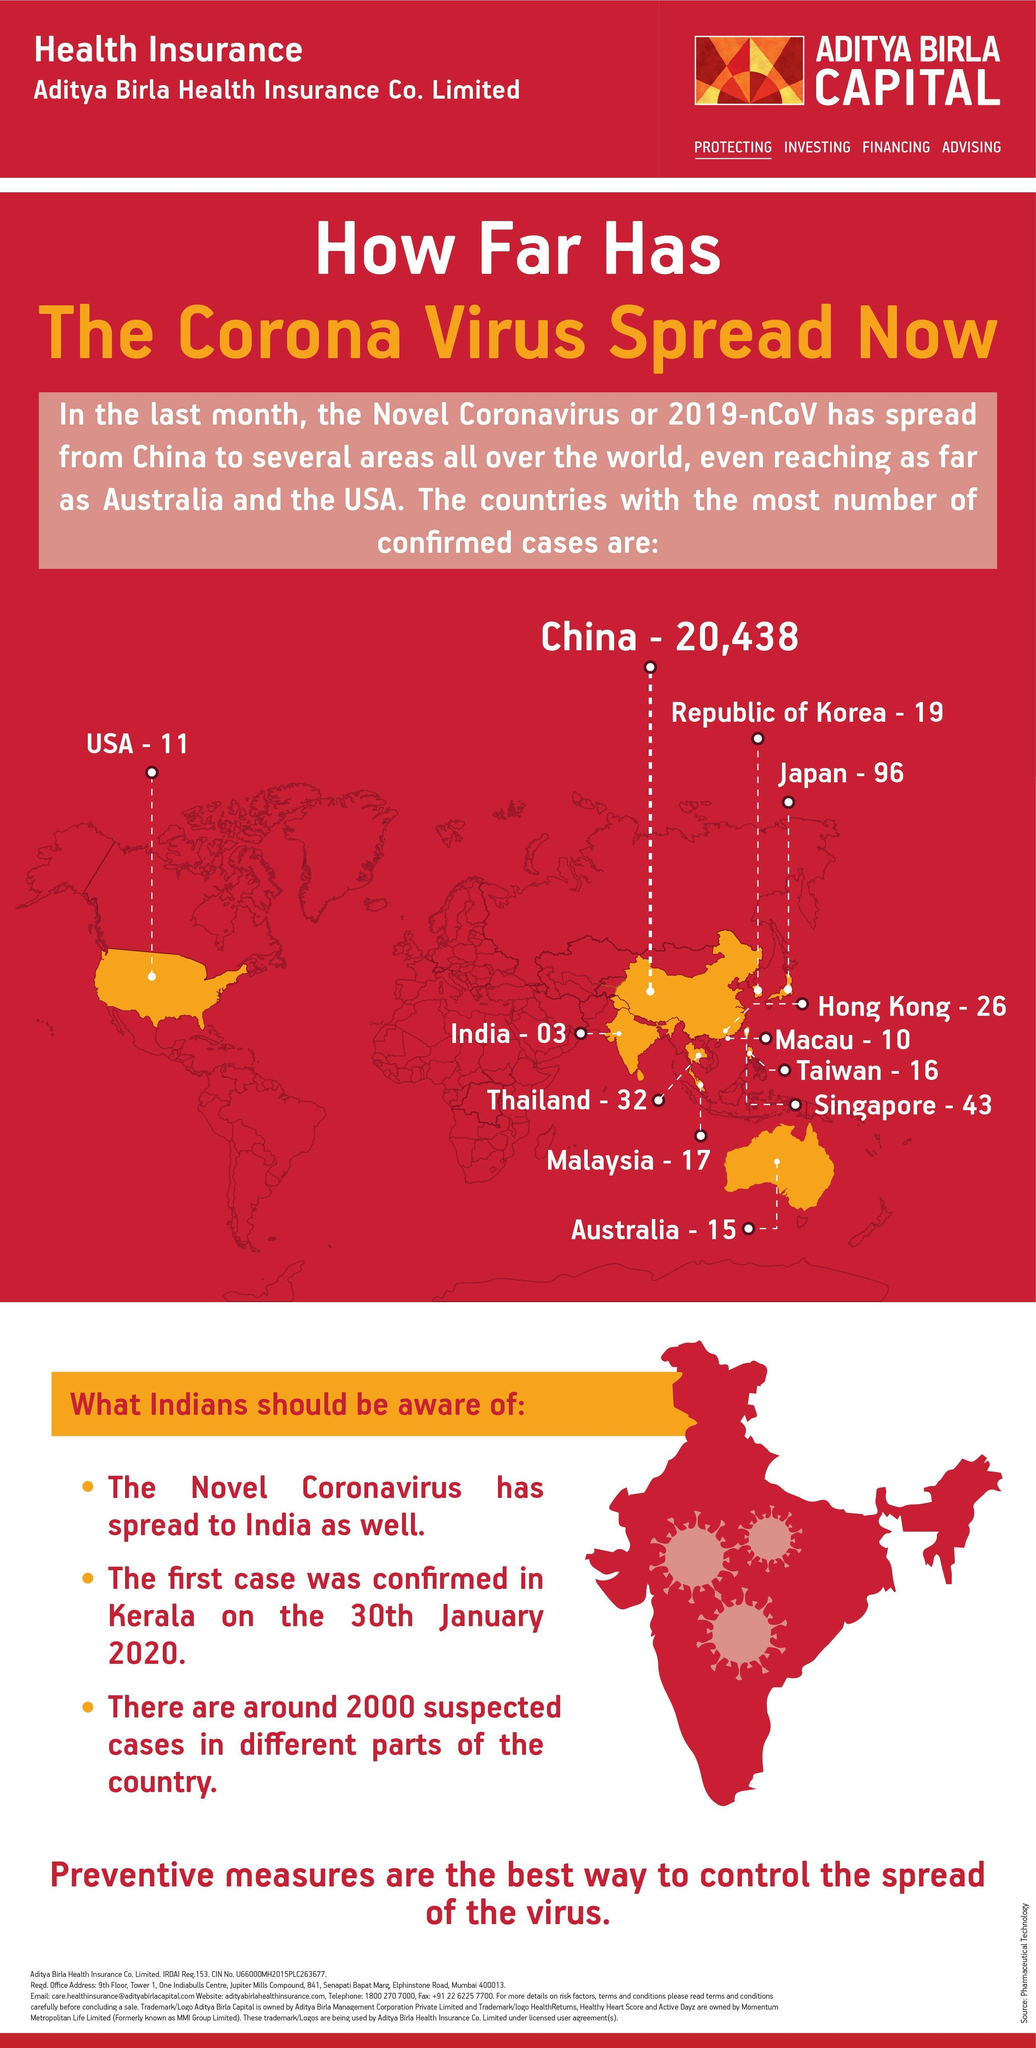How many confirmed positive cases of COVID-19 were reported in India?
Answer the question with a short phrase. 03 Which country has reported the second highest number of confirmed COVID-19 cases among the given countries? Japan Which country has reported the third highest number of confirmed COVID-19 cases among the given countries? Singapore How many confirmed positive cases of COVID-19 were reported in Australia? 15 